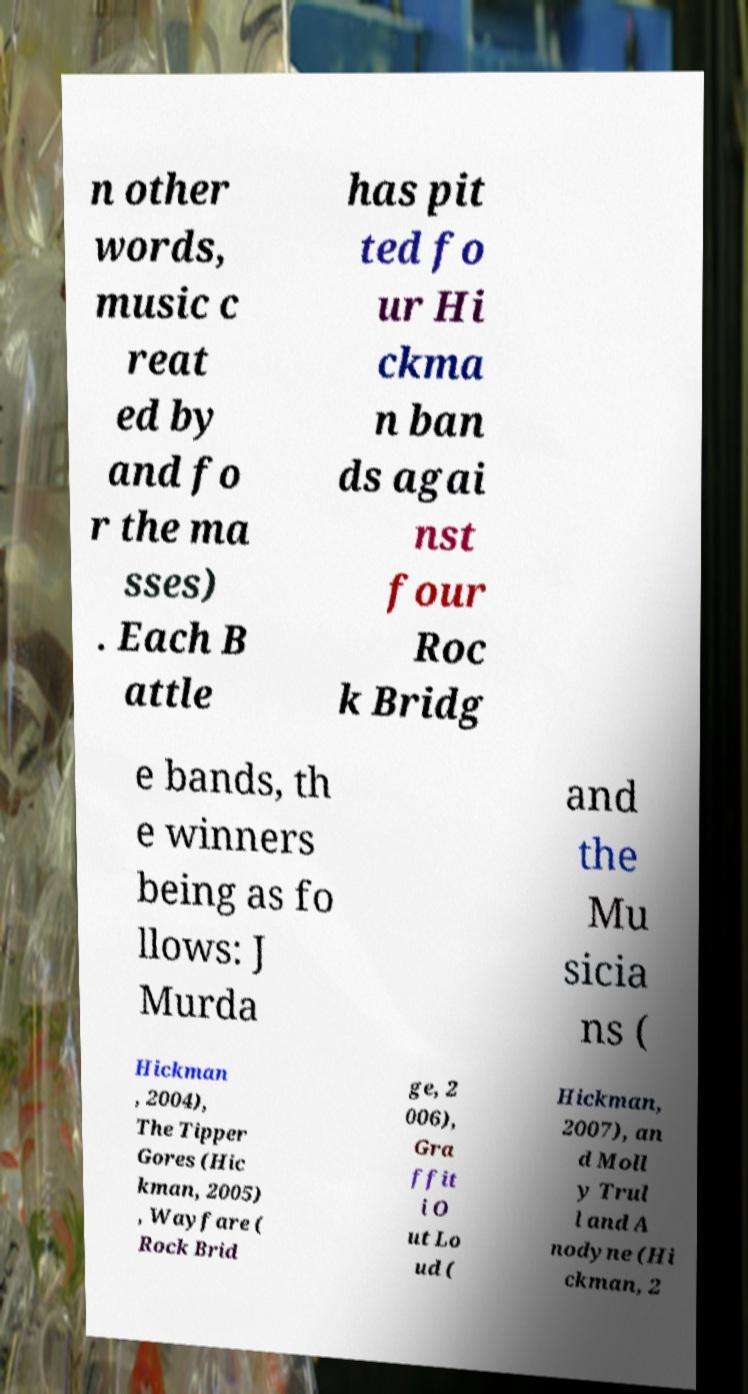There's text embedded in this image that I need extracted. Can you transcribe it verbatim? n other words, music c reat ed by and fo r the ma sses) . Each B attle has pit ted fo ur Hi ckma n ban ds agai nst four Roc k Bridg e bands, th e winners being as fo llows: J Murda and the Mu sicia ns ( Hickman , 2004), The Tipper Gores (Hic kman, 2005) , Wayfare ( Rock Brid ge, 2 006), Gra ffit i O ut Lo ud ( Hickman, 2007), an d Moll y Trul l and A nodyne (Hi ckman, 2 